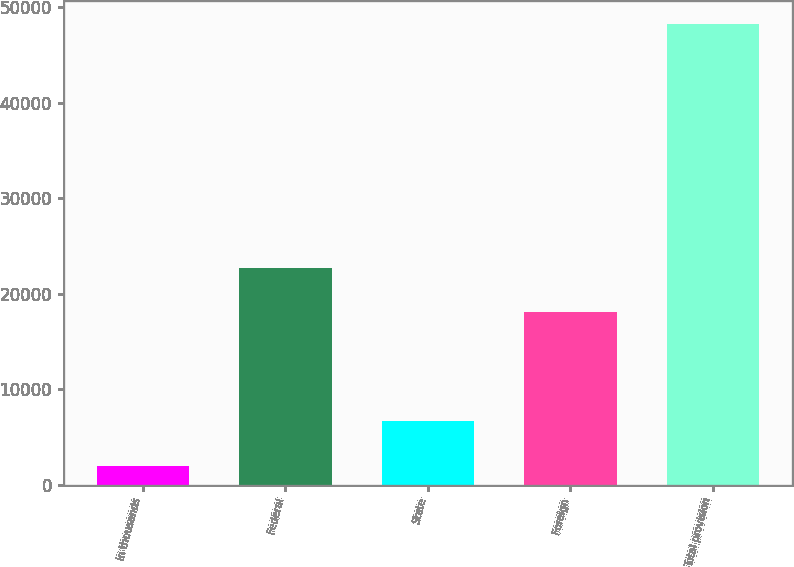<chart> <loc_0><loc_0><loc_500><loc_500><bar_chart><fcel>In thousands<fcel>Federal<fcel>State<fcel>Foreign<fcel>Total provision<nl><fcel>2009<fcel>22743.5<fcel>6638.5<fcel>18114<fcel>48304<nl></chart> 